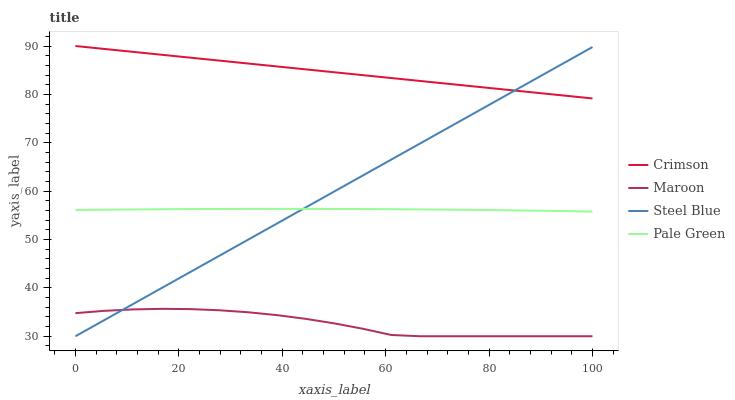Does Maroon have the minimum area under the curve?
Answer yes or no. Yes. Does Crimson have the maximum area under the curve?
Answer yes or no. Yes. Does Pale Green have the minimum area under the curve?
Answer yes or no. No. Does Pale Green have the maximum area under the curve?
Answer yes or no. No. Is Steel Blue the smoothest?
Answer yes or no. Yes. Is Maroon the roughest?
Answer yes or no. Yes. Is Pale Green the smoothest?
Answer yes or no. No. Is Pale Green the roughest?
Answer yes or no. No. Does Steel Blue have the lowest value?
Answer yes or no. Yes. Does Pale Green have the lowest value?
Answer yes or no. No. Does Crimson have the highest value?
Answer yes or no. Yes. Does Pale Green have the highest value?
Answer yes or no. No. Is Maroon less than Pale Green?
Answer yes or no. Yes. Is Crimson greater than Maroon?
Answer yes or no. Yes. Does Crimson intersect Steel Blue?
Answer yes or no. Yes. Is Crimson less than Steel Blue?
Answer yes or no. No. Is Crimson greater than Steel Blue?
Answer yes or no. No. Does Maroon intersect Pale Green?
Answer yes or no. No. 